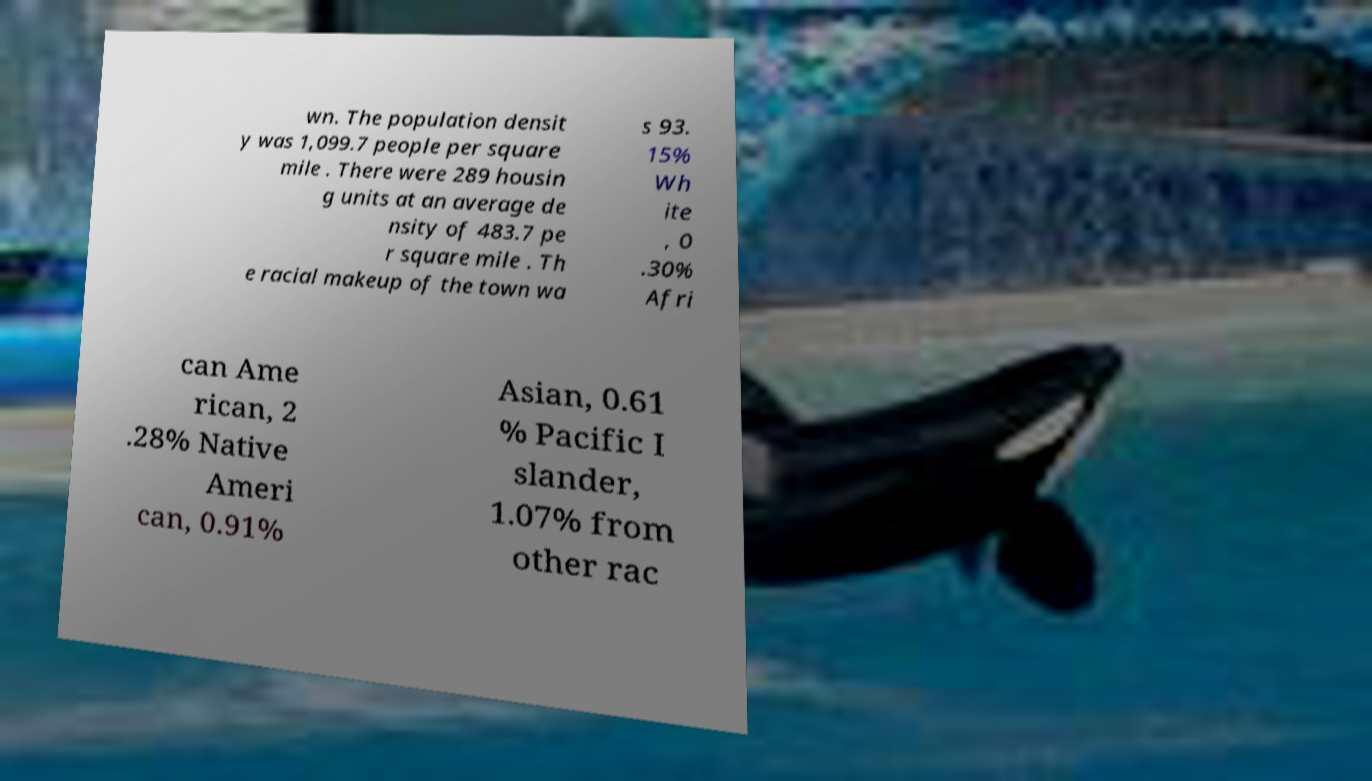For documentation purposes, I need the text within this image transcribed. Could you provide that? wn. The population densit y was 1,099.7 people per square mile . There were 289 housin g units at an average de nsity of 483.7 pe r square mile . Th e racial makeup of the town wa s 93. 15% Wh ite , 0 .30% Afri can Ame rican, 2 .28% Native Ameri can, 0.91% Asian, 0.61 % Pacific I slander, 1.07% from other rac 